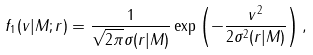<formula> <loc_0><loc_0><loc_500><loc_500>f _ { 1 } ( v | M ; r ) = \frac { 1 } { \sqrt { 2 \pi } \sigma ( r | M ) } \exp \left ( - \frac { v ^ { 2 } } { 2 \sigma ^ { 2 } ( r | M ) } \right ) ,</formula> 